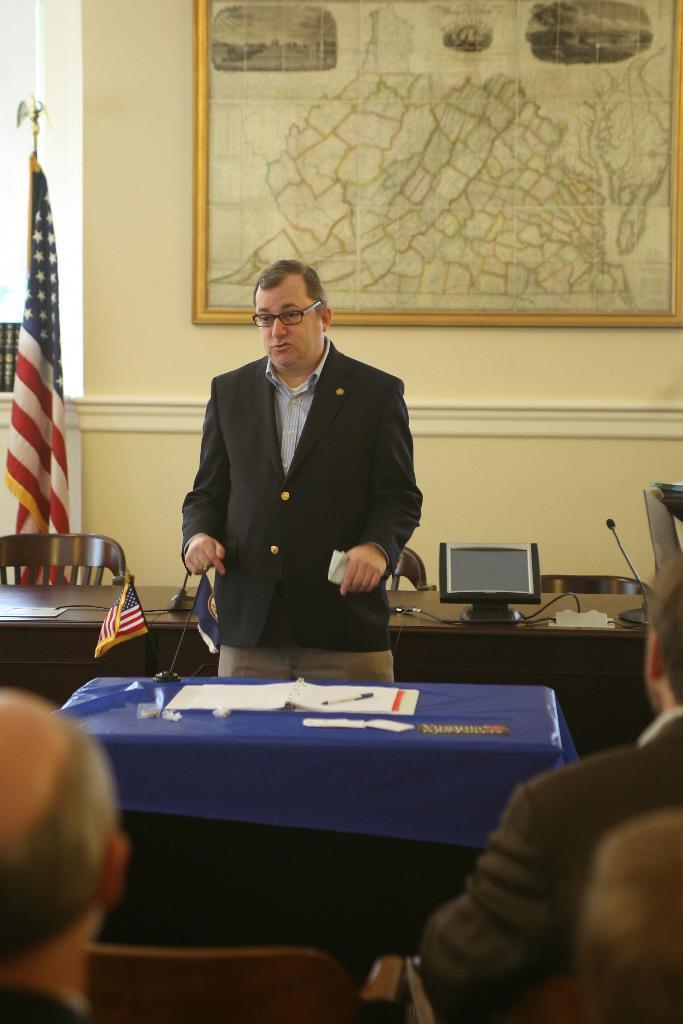Please provide a concise description of this image. This image consist of a man standing in the front and wearing a black suit. In front of him, there is a table covered with blue cover on which there are books. To the left, there is a flag. In the background, there is a wall on which a frame is fixed. at the bottom there are people sitting. 